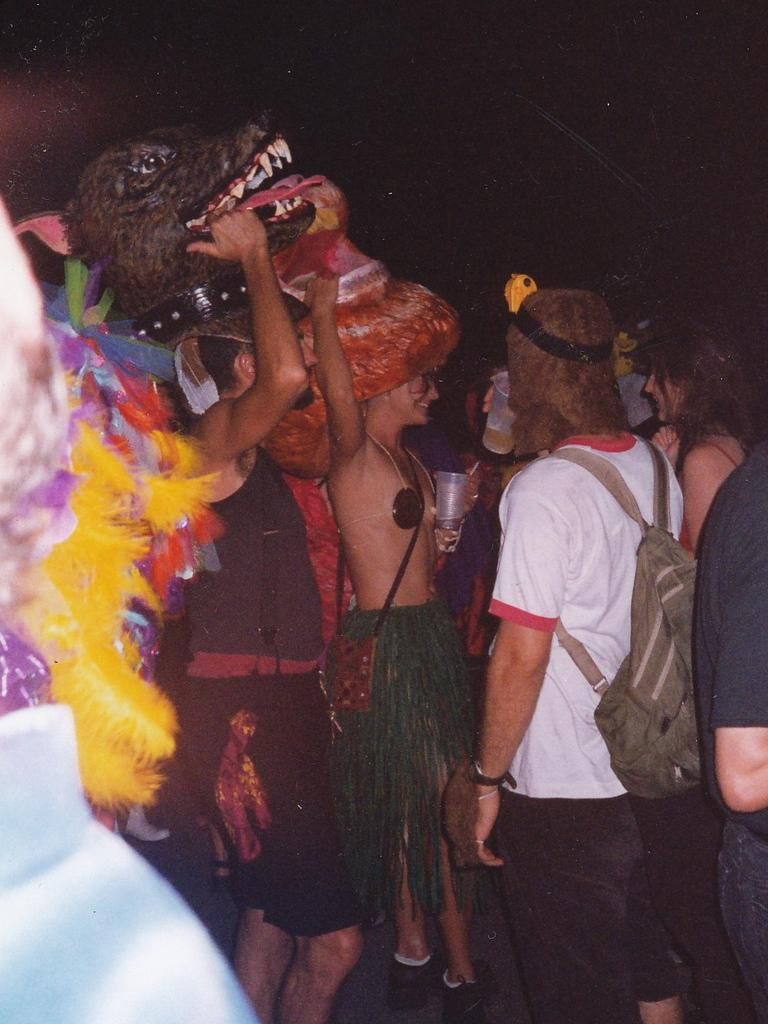How many people are in the image? There are people in the image, but the exact number is not specified. What is the people's position in the image? The people are standing on the floor. What type of plant is growing in the mine in the image? There is no mention of a mine or a plant in the image, so this question cannot be answered. 